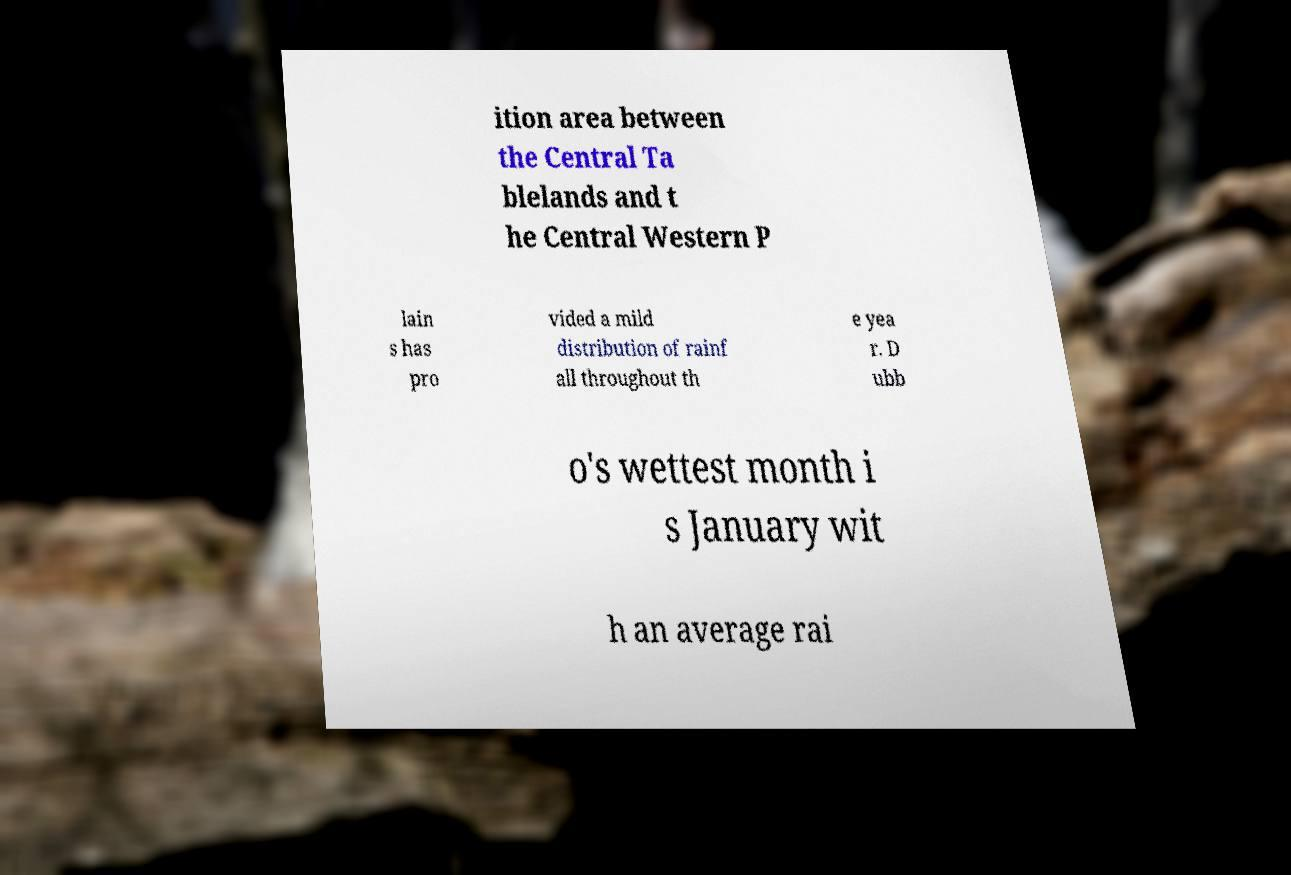Please identify and transcribe the text found in this image. ition area between the Central Ta blelands and t he Central Western P lain s has pro vided a mild distribution of rainf all throughout th e yea r. D ubb o's wettest month i s January wit h an average rai 